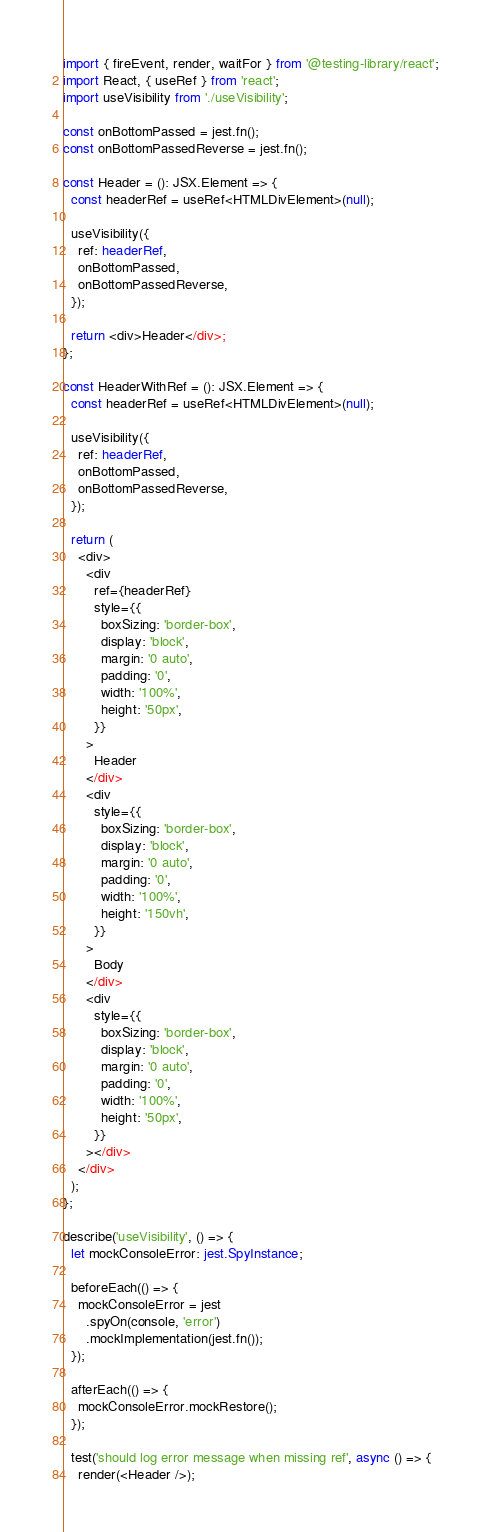Convert code to text. <code><loc_0><loc_0><loc_500><loc_500><_TypeScript_>import { fireEvent, render, waitFor } from '@testing-library/react';
import React, { useRef } from 'react';
import useVisibility from './useVisibility';

const onBottomPassed = jest.fn();
const onBottomPassedReverse = jest.fn();

const Header = (): JSX.Element => {
  const headerRef = useRef<HTMLDivElement>(null);

  useVisibility({
    ref: headerRef,
    onBottomPassed,
    onBottomPassedReverse,
  });

  return <div>Header</div>;
};

const HeaderWithRef = (): JSX.Element => {
  const headerRef = useRef<HTMLDivElement>(null);

  useVisibility({
    ref: headerRef,
    onBottomPassed,
    onBottomPassedReverse,
  });

  return (
    <div>
      <div
        ref={headerRef}
        style={{
          boxSizing: 'border-box',
          display: 'block',
          margin: '0 auto',
          padding: '0',
          width: '100%',
          height: '50px',
        }}
      >
        Header
      </div>
      <div
        style={{
          boxSizing: 'border-box',
          display: 'block',
          margin: '0 auto',
          padding: '0',
          width: '100%',
          height: '150vh',
        }}
      >
        Body
      </div>
      <div
        style={{
          boxSizing: 'border-box',
          display: 'block',
          margin: '0 auto',
          padding: '0',
          width: '100%',
          height: '50px',
        }}
      ></div>
    </div>
  );
};

describe('useVisibility', () => {
  let mockConsoleError: jest.SpyInstance;

  beforeEach(() => {
    mockConsoleError = jest
      .spyOn(console, 'error')
      .mockImplementation(jest.fn());
  });

  afterEach(() => {
    mockConsoleError.mockRestore();
  });

  test('should log error message when missing ref', async () => {
    render(<Header />);</code> 